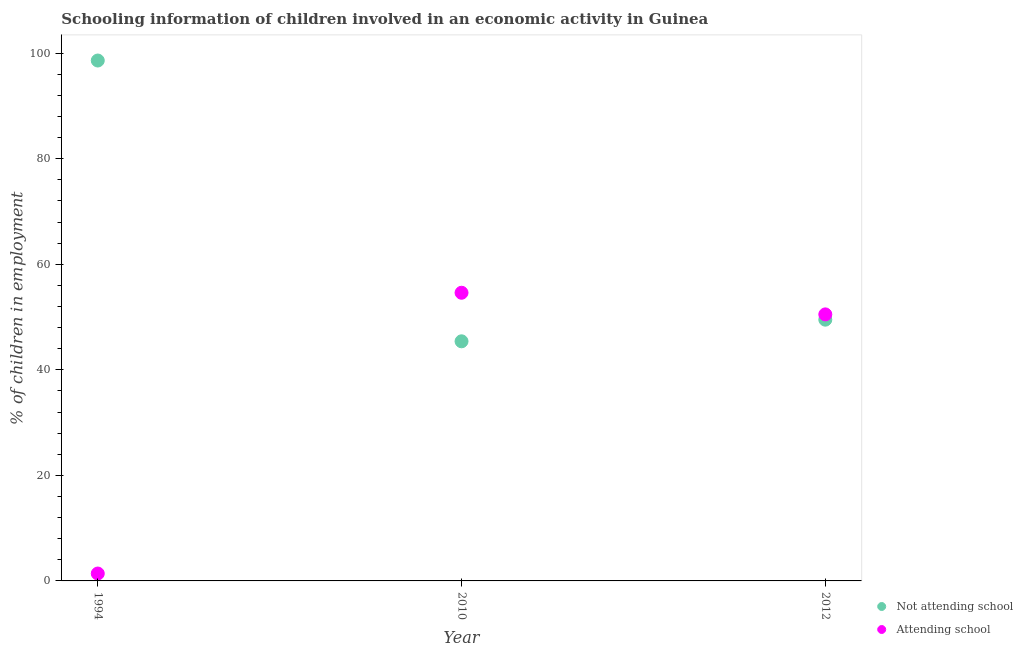How many different coloured dotlines are there?
Offer a terse response. 2. What is the percentage of employed children who are attending school in 2010?
Your answer should be very brief. 54.6. Across all years, what is the maximum percentage of employed children who are not attending school?
Your answer should be compact. 98.6. Across all years, what is the minimum percentage of employed children who are attending school?
Keep it short and to the point. 1.4. In which year was the percentage of employed children who are not attending school minimum?
Keep it short and to the point. 2010. What is the total percentage of employed children who are not attending school in the graph?
Your response must be concise. 193.5. What is the difference between the percentage of employed children who are not attending school in 1994 and that in 2012?
Ensure brevity in your answer.  49.1. What is the difference between the percentage of employed children who are attending school in 2010 and the percentage of employed children who are not attending school in 2012?
Provide a short and direct response. 5.1. What is the average percentage of employed children who are attending school per year?
Provide a succinct answer. 35.5. In the year 1994, what is the difference between the percentage of employed children who are attending school and percentage of employed children who are not attending school?
Offer a very short reply. -97.2. What is the ratio of the percentage of employed children who are attending school in 2010 to that in 2012?
Ensure brevity in your answer.  1.08. Is the percentage of employed children who are attending school in 1994 less than that in 2010?
Offer a terse response. Yes. What is the difference between the highest and the second highest percentage of employed children who are attending school?
Offer a very short reply. 4.1. What is the difference between the highest and the lowest percentage of employed children who are not attending school?
Offer a terse response. 53.2. Does the percentage of employed children who are not attending school monotonically increase over the years?
Your answer should be compact. No. Is the percentage of employed children who are not attending school strictly greater than the percentage of employed children who are attending school over the years?
Make the answer very short. No. Is the percentage of employed children who are attending school strictly less than the percentage of employed children who are not attending school over the years?
Give a very brief answer. No. How many dotlines are there?
Make the answer very short. 2. How many years are there in the graph?
Keep it short and to the point. 3. What is the difference between two consecutive major ticks on the Y-axis?
Ensure brevity in your answer.  20. Where does the legend appear in the graph?
Keep it short and to the point. Bottom right. How many legend labels are there?
Offer a very short reply. 2. What is the title of the graph?
Provide a succinct answer. Schooling information of children involved in an economic activity in Guinea. What is the label or title of the Y-axis?
Ensure brevity in your answer.  % of children in employment. What is the % of children in employment of Not attending school in 1994?
Provide a short and direct response. 98.6. What is the % of children in employment in Attending school in 1994?
Your answer should be compact. 1.4. What is the % of children in employment in Not attending school in 2010?
Offer a very short reply. 45.4. What is the % of children in employment of Attending school in 2010?
Give a very brief answer. 54.6. What is the % of children in employment of Not attending school in 2012?
Make the answer very short. 49.5. What is the % of children in employment in Attending school in 2012?
Offer a very short reply. 50.5. Across all years, what is the maximum % of children in employment in Not attending school?
Provide a succinct answer. 98.6. Across all years, what is the maximum % of children in employment of Attending school?
Your answer should be very brief. 54.6. Across all years, what is the minimum % of children in employment of Not attending school?
Offer a terse response. 45.4. Across all years, what is the minimum % of children in employment in Attending school?
Make the answer very short. 1.4. What is the total % of children in employment in Not attending school in the graph?
Provide a succinct answer. 193.5. What is the total % of children in employment of Attending school in the graph?
Your answer should be very brief. 106.5. What is the difference between the % of children in employment of Not attending school in 1994 and that in 2010?
Offer a very short reply. 53.2. What is the difference between the % of children in employment in Attending school in 1994 and that in 2010?
Make the answer very short. -53.2. What is the difference between the % of children in employment in Not attending school in 1994 and that in 2012?
Your answer should be compact. 49.1. What is the difference between the % of children in employment in Attending school in 1994 and that in 2012?
Ensure brevity in your answer.  -49.1. What is the difference between the % of children in employment in Not attending school in 2010 and that in 2012?
Ensure brevity in your answer.  -4.1. What is the difference between the % of children in employment in Attending school in 2010 and that in 2012?
Your answer should be compact. 4.1. What is the difference between the % of children in employment in Not attending school in 1994 and the % of children in employment in Attending school in 2012?
Offer a very short reply. 48.1. What is the average % of children in employment in Not attending school per year?
Give a very brief answer. 64.5. What is the average % of children in employment of Attending school per year?
Your answer should be compact. 35.5. In the year 1994, what is the difference between the % of children in employment of Not attending school and % of children in employment of Attending school?
Offer a very short reply. 97.2. In the year 2012, what is the difference between the % of children in employment in Not attending school and % of children in employment in Attending school?
Keep it short and to the point. -1. What is the ratio of the % of children in employment in Not attending school in 1994 to that in 2010?
Provide a short and direct response. 2.17. What is the ratio of the % of children in employment in Attending school in 1994 to that in 2010?
Your response must be concise. 0.03. What is the ratio of the % of children in employment of Not attending school in 1994 to that in 2012?
Your answer should be compact. 1.99. What is the ratio of the % of children in employment of Attending school in 1994 to that in 2012?
Provide a short and direct response. 0.03. What is the ratio of the % of children in employment in Not attending school in 2010 to that in 2012?
Provide a short and direct response. 0.92. What is the ratio of the % of children in employment in Attending school in 2010 to that in 2012?
Give a very brief answer. 1.08. What is the difference between the highest and the second highest % of children in employment of Not attending school?
Give a very brief answer. 49.1. What is the difference between the highest and the lowest % of children in employment in Not attending school?
Your response must be concise. 53.2. What is the difference between the highest and the lowest % of children in employment of Attending school?
Give a very brief answer. 53.2. 